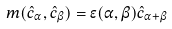<formula> <loc_0><loc_0><loc_500><loc_500>m ( \hat { c } _ { \alpha } , \hat { c } _ { \beta } ) = \epsilon ( \alpha , \beta ) \hat { c } _ { \alpha + \beta }</formula> 